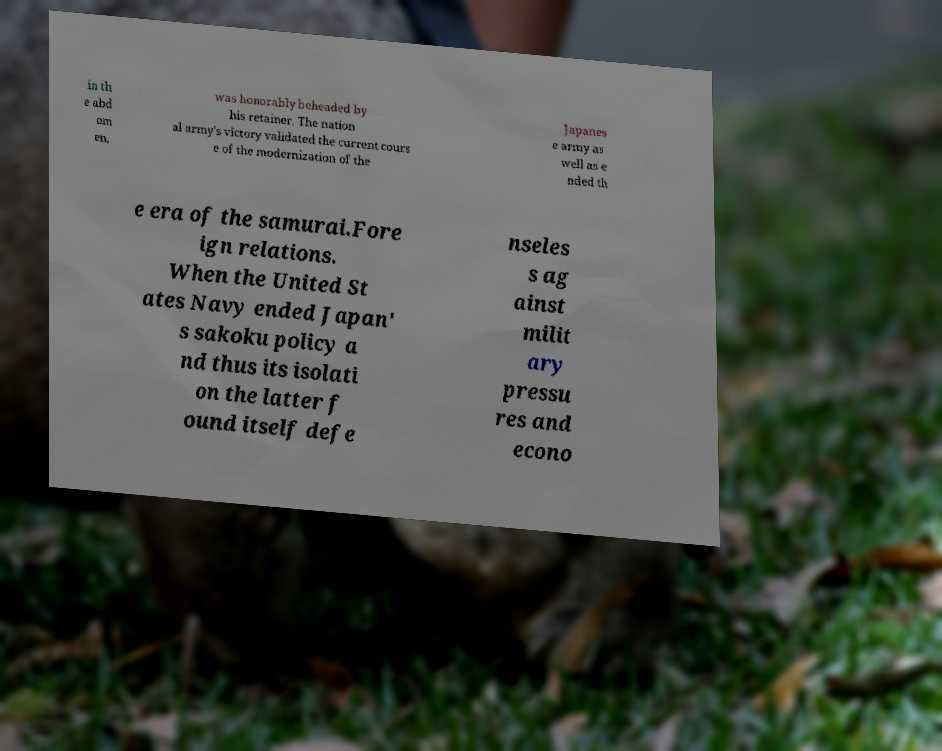There's text embedded in this image that I need extracted. Can you transcribe it verbatim? in th e abd om en, was honorably beheaded by his retainer. The nation al army's victory validated the current cours e of the modernization of the Japanes e army as well as e nded th e era of the samurai.Fore ign relations. When the United St ates Navy ended Japan' s sakoku policy a nd thus its isolati on the latter f ound itself defe nseles s ag ainst milit ary pressu res and econo 